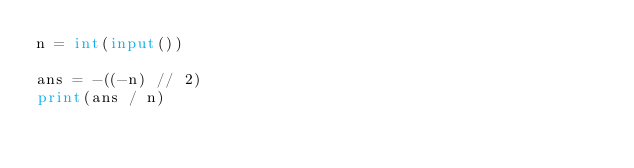Convert code to text. <code><loc_0><loc_0><loc_500><loc_500><_Python_>n = int(input())

ans = -((-n) // 2)
print(ans / n)</code> 